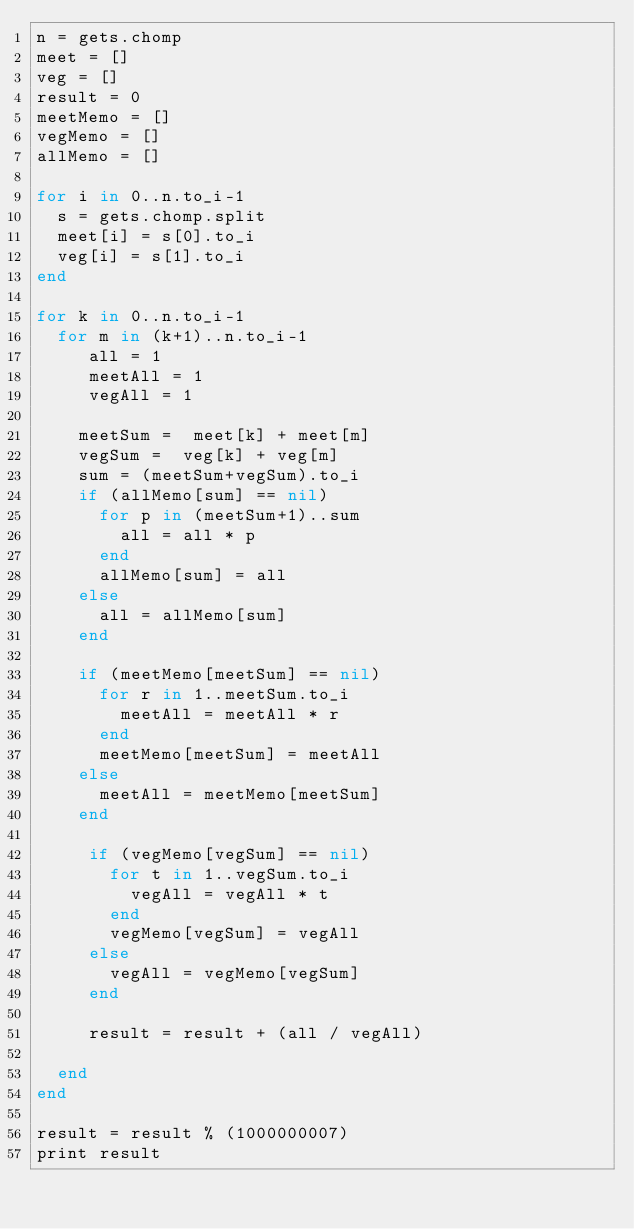<code> <loc_0><loc_0><loc_500><loc_500><_Ruby_>n = gets.chomp
meet = []
veg = []
result = 0
meetMemo = []
vegMemo = []
allMemo = []

for i in 0..n.to_i-1
  s = gets.chomp.split
  meet[i] = s[0].to_i
  veg[i] = s[1].to_i
end

for k in 0..n.to_i-1
  for m in (k+1)..n.to_i-1
     all = 1
     meetAll = 1
     vegAll = 1
  
    meetSum =  meet[k] + meet[m]
    vegSum =  veg[k] + veg[m]
    sum = (meetSum+vegSum).to_i
    if (allMemo[sum] == nil)
      for p in (meetSum+1)..sum
        all = all * p
      end
      allMemo[sum] = all
    else
      all = allMemo[sum]
    end
    
    if (meetMemo[meetSum] == nil)
      for r in 1..meetSum.to_i
        meetAll = meetAll * r
      end
      meetMemo[meetSum] = meetAll
    else
      meetAll = meetMemo[meetSum]
    end

     if (vegMemo[vegSum] == nil)
       for t in 1..vegSum.to_i
         vegAll = vegAll * t
       end
       vegMemo[vegSum] = vegAll 
     else
       vegAll = vegMemo[vegSum]
     end
    
     result = result + (all / vegAll)
    
  end
end

result = result % (1000000007)
print result

</code> 